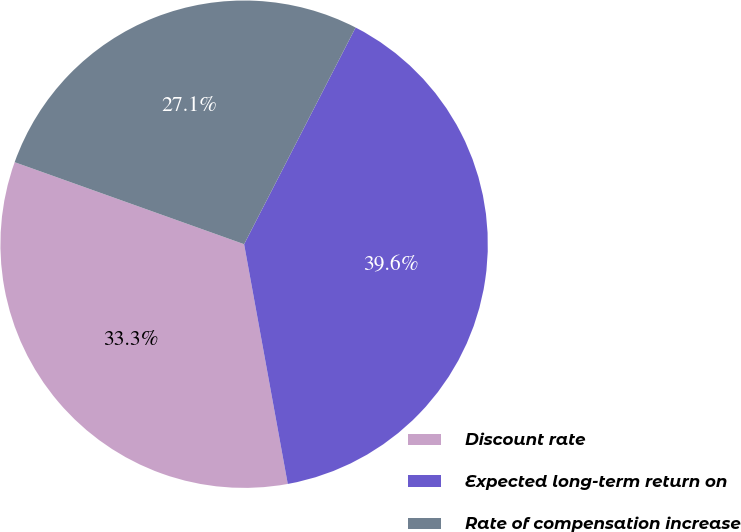Convert chart. <chart><loc_0><loc_0><loc_500><loc_500><pie_chart><fcel>Discount rate<fcel>Expected long-term return on<fcel>Rate of compensation increase<nl><fcel>33.33%<fcel>39.57%<fcel>27.1%<nl></chart> 